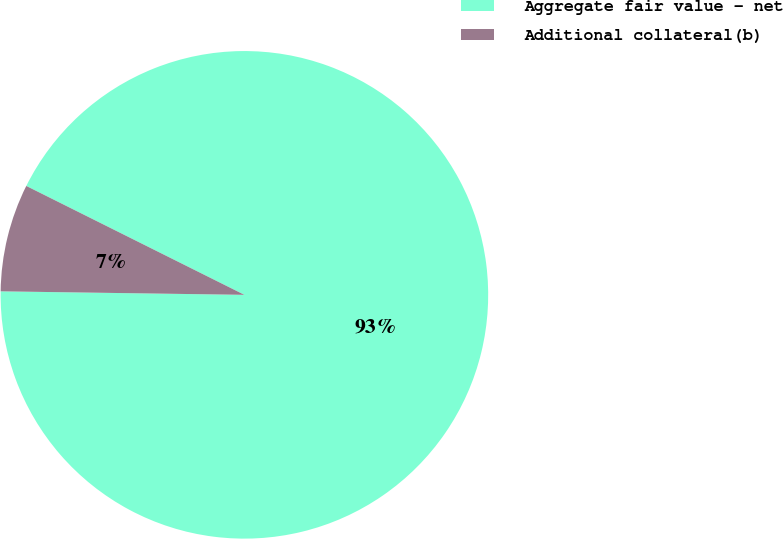Convert chart to OTSL. <chart><loc_0><loc_0><loc_500><loc_500><pie_chart><fcel>Aggregate fair value - net<fcel>Additional collateral(b)<nl><fcel>92.86%<fcel>7.14%<nl></chart> 